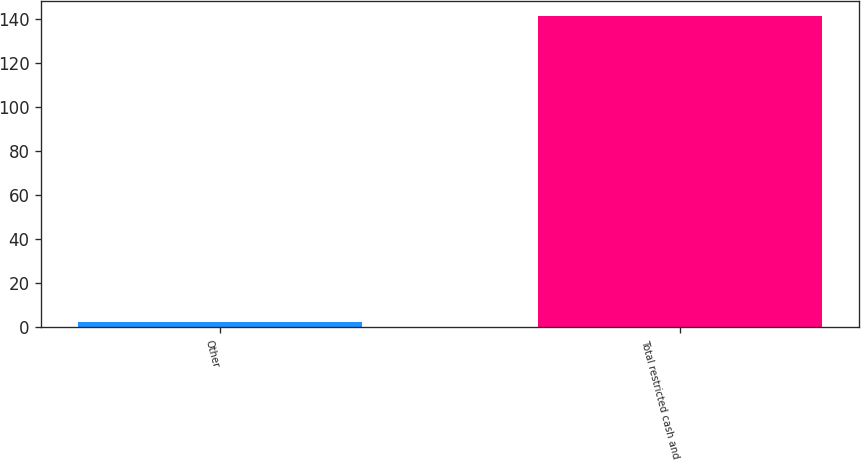Convert chart. <chart><loc_0><loc_0><loc_500><loc_500><bar_chart><fcel>Other<fcel>Total restricted cash and<nl><fcel>2.5<fcel>141.1<nl></chart> 